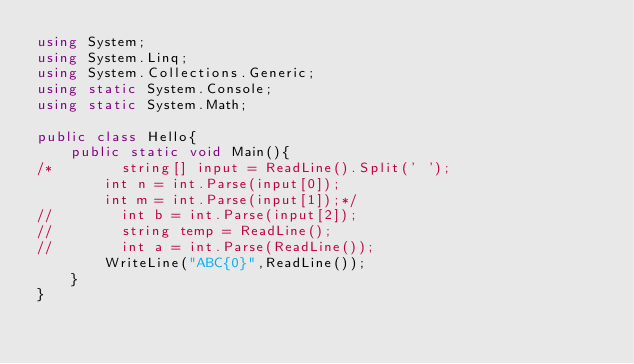Convert code to text. <code><loc_0><loc_0><loc_500><loc_500><_C#_>using System;
using System.Linq;
using System.Collections.Generic;
using static System.Console;
using static System.Math;
 
public class Hello{
    public static void Main(){
/*        string[] input = ReadLine().Split(' ');
        int n = int.Parse(input[0]);
        int m = int.Parse(input[1]);*/
//        int b = int.Parse(input[2]);
//        string temp = ReadLine();
//        int a = int.Parse(ReadLine());
        WriteLine("ABC{0}",ReadLine());
    }
}</code> 